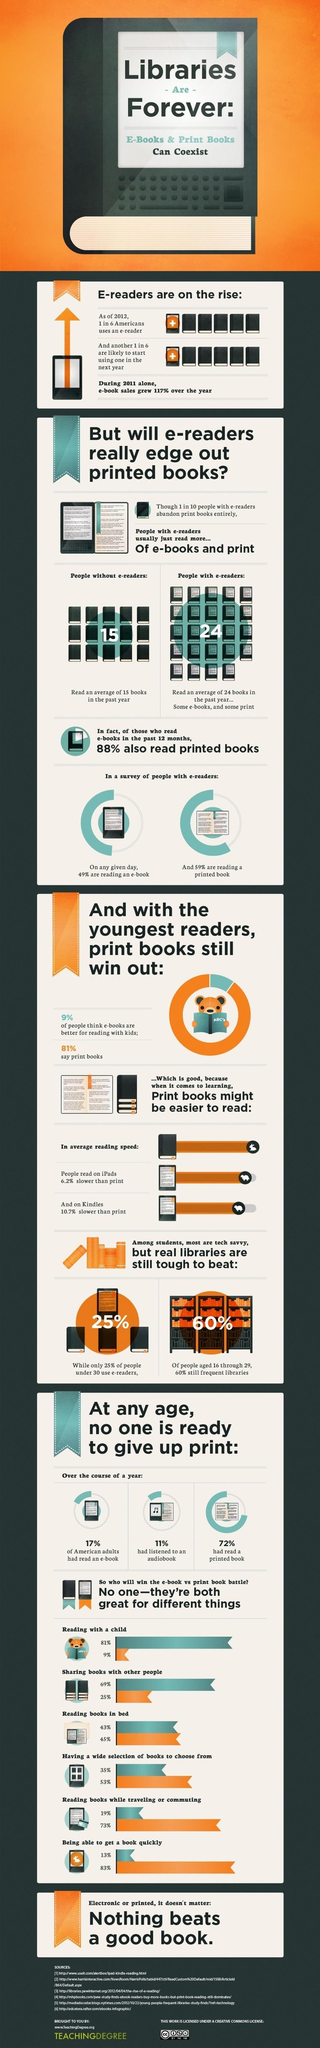Identify some key points in this picture. According to a recent survey, approximately 11% of people had listened to an audiobook in the past year. According to a survey, 17% of American adults had read an e-book over the past year. A large percentage of people under the age of 30 did not use e-readers. Seventy-two percent of the sample had read a printed book within the past year, 